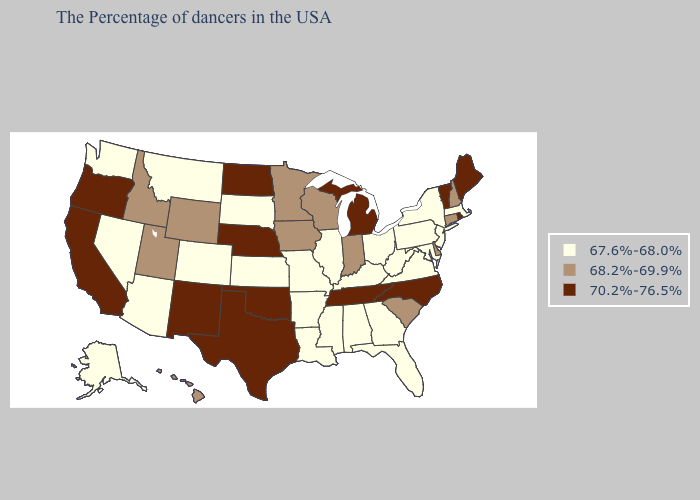Among the states that border California , does Oregon have the lowest value?
Quick response, please. No. Does Alaska have the lowest value in the USA?
Quick response, please. Yes. Name the states that have a value in the range 68.2%-69.9%?
Write a very short answer. New Hampshire, Connecticut, Delaware, South Carolina, Indiana, Wisconsin, Minnesota, Iowa, Wyoming, Utah, Idaho, Hawaii. Does the map have missing data?
Answer briefly. No. Does Colorado have a lower value than Rhode Island?
Answer briefly. Yes. What is the value of Alabama?
Give a very brief answer. 67.6%-68.0%. Does Wyoming have the lowest value in the USA?
Answer briefly. No. Does Mississippi have the lowest value in the USA?
Keep it brief. Yes. What is the lowest value in states that border Louisiana?
Be succinct. 67.6%-68.0%. Name the states that have a value in the range 68.2%-69.9%?
Give a very brief answer. New Hampshire, Connecticut, Delaware, South Carolina, Indiana, Wisconsin, Minnesota, Iowa, Wyoming, Utah, Idaho, Hawaii. Which states have the highest value in the USA?
Give a very brief answer. Maine, Rhode Island, Vermont, North Carolina, Michigan, Tennessee, Nebraska, Oklahoma, Texas, North Dakota, New Mexico, California, Oregon. What is the value of California?
Be succinct. 70.2%-76.5%. What is the lowest value in the Northeast?
Give a very brief answer. 67.6%-68.0%. Does Michigan have the highest value in the MidWest?
Write a very short answer. Yes. Name the states that have a value in the range 68.2%-69.9%?
Keep it brief. New Hampshire, Connecticut, Delaware, South Carolina, Indiana, Wisconsin, Minnesota, Iowa, Wyoming, Utah, Idaho, Hawaii. 